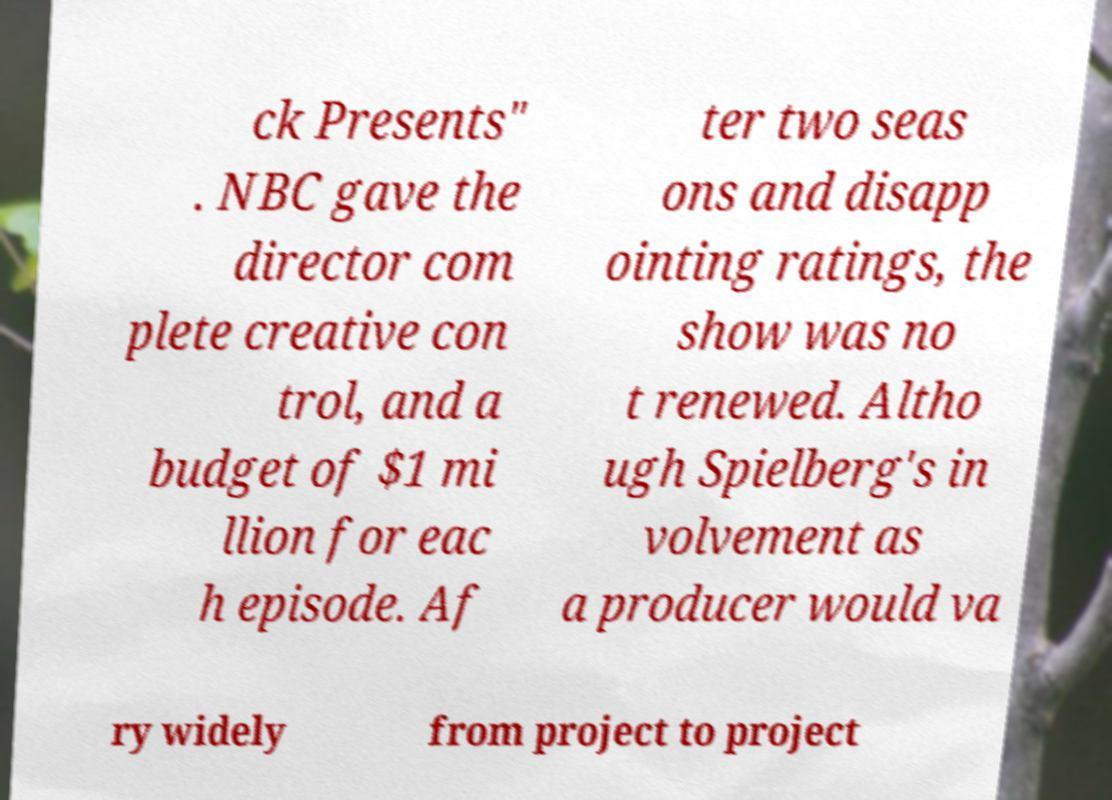Could you extract and type out the text from this image? ck Presents" . NBC gave the director com plete creative con trol, and a budget of $1 mi llion for eac h episode. Af ter two seas ons and disapp ointing ratings, the show was no t renewed. Altho ugh Spielberg's in volvement as a producer would va ry widely from project to project 